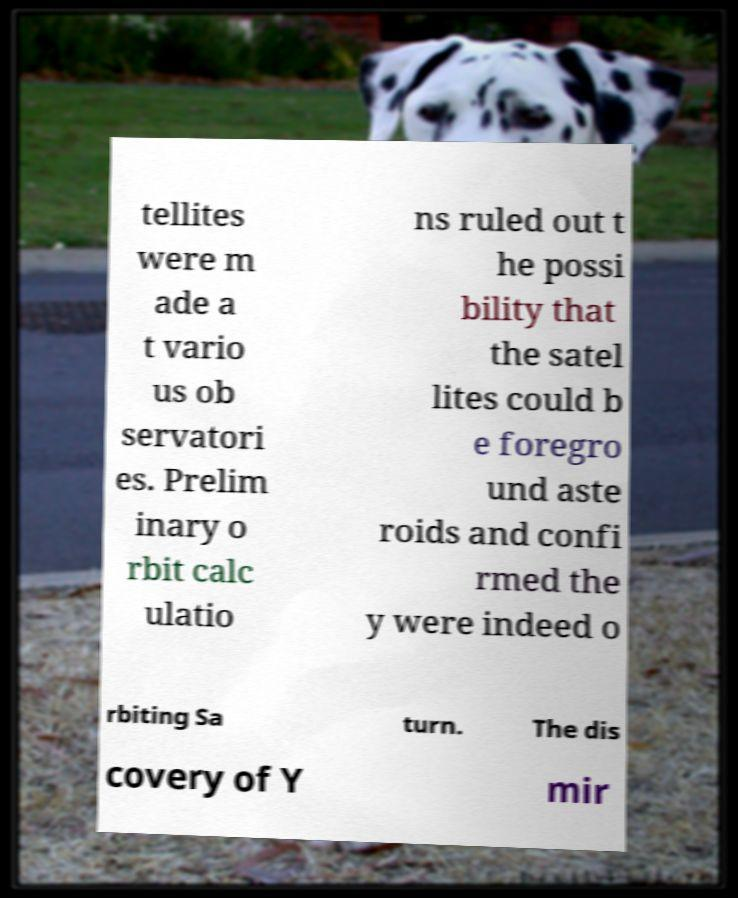There's text embedded in this image that I need extracted. Can you transcribe it verbatim? tellites were m ade a t vario us ob servatori es. Prelim inary o rbit calc ulatio ns ruled out t he possi bility that the satel lites could b e foregro und aste roids and confi rmed the y were indeed o rbiting Sa turn. The dis covery of Y mir 